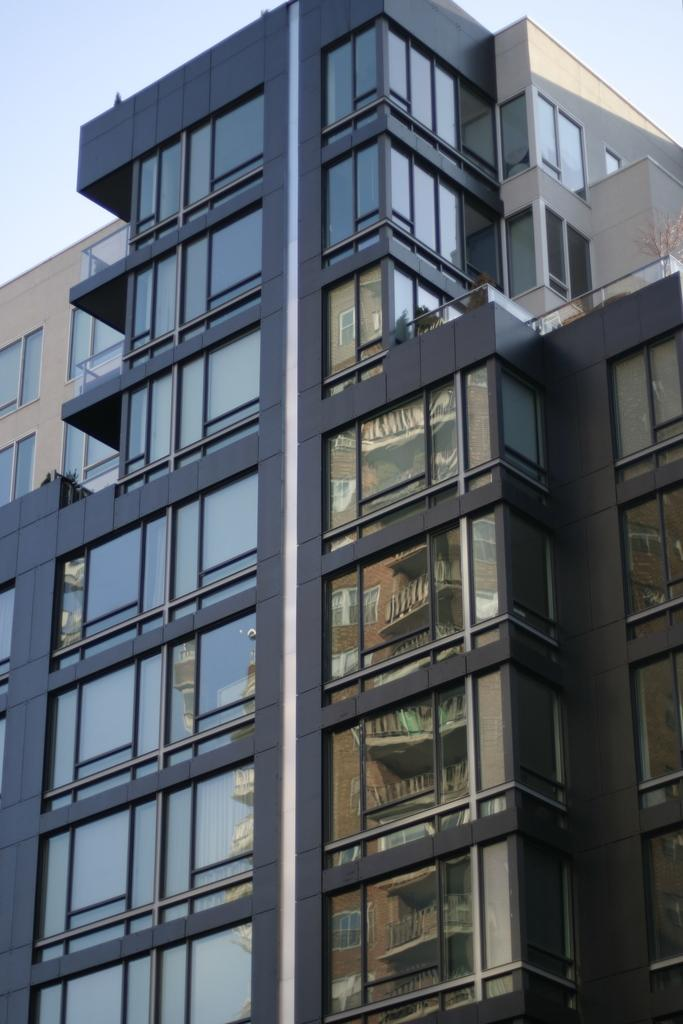What type of structure is present in the image? There is a building in the image. What feature can be observed on the building? The building has multiple glass windows. What do the glass windows reflect in the image? The glass windows reflect another building. What is visible at the top of the image? The sky is visible at the top of the image. What type of wax can be seen melting on the building in the image? There is no wax present in the image; the building has glass windows that reflect another building. 